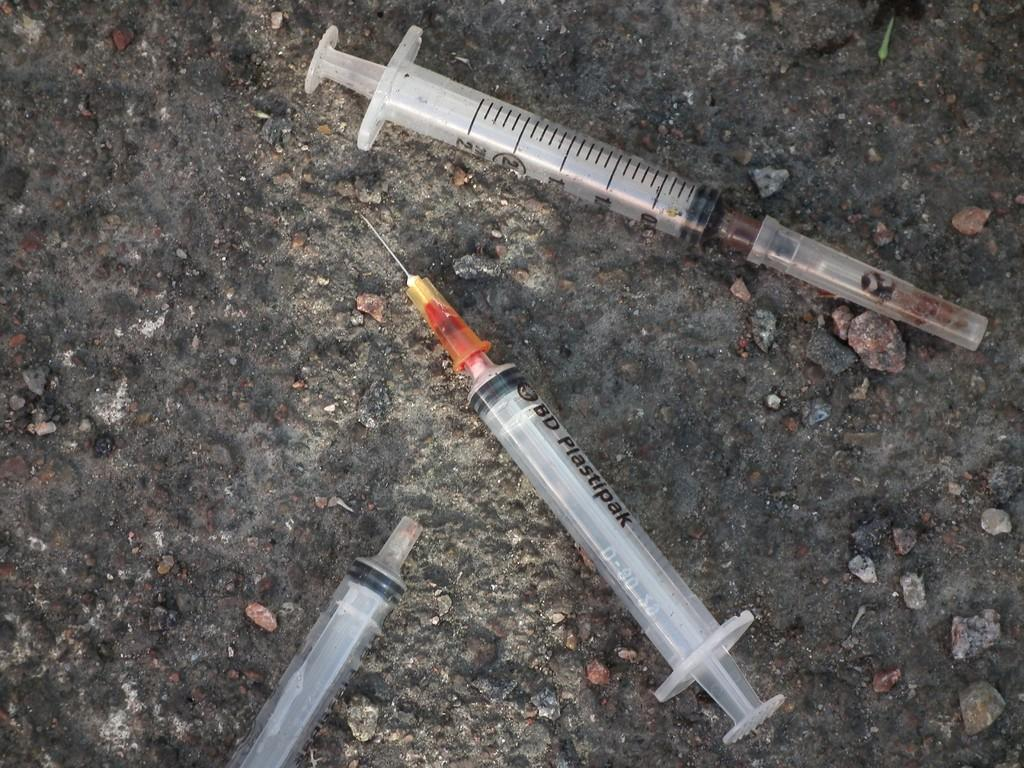What objects are on the ground in the image? There are syringes on the ground in the image. Are there any specific features of the syringes? Yes, there is a needle attached to one of the syringes. How many kittens are sitting on the suit in the image? There are no kittens or suit present in the image; it only features syringes on the ground. 